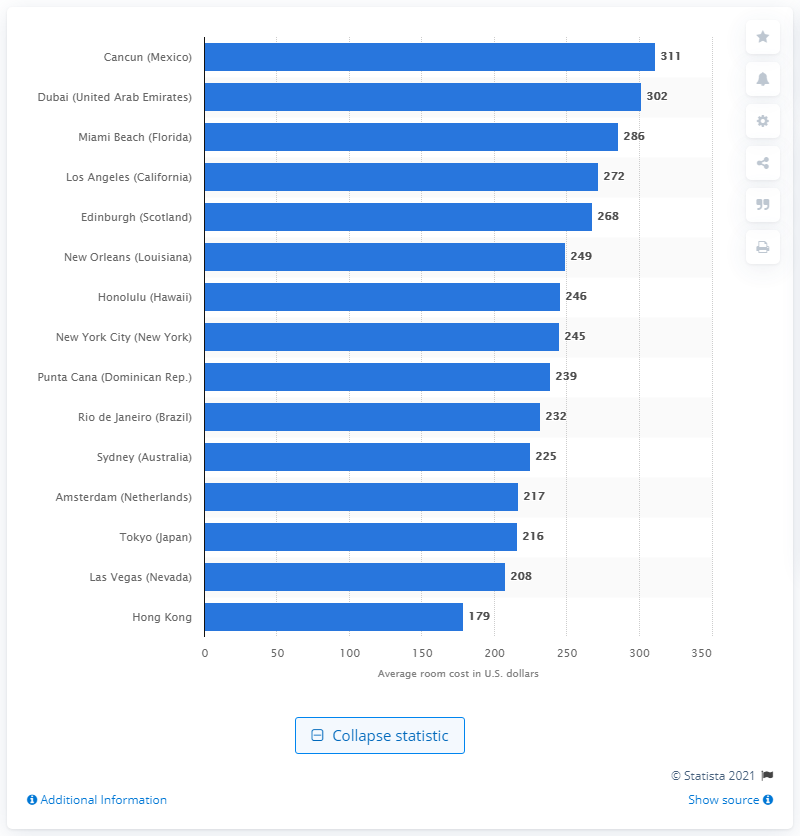Highlight a few significant elements in this photo. The average cost of a New Year's Eve room in Cancun was 311. 